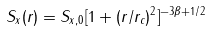Convert formula to latex. <formula><loc_0><loc_0><loc_500><loc_500>S _ { x } ( r ) = S _ { x , 0 } [ 1 + ( r / r _ { c } ) ^ { 2 } ] ^ { - 3 \beta + 1 / 2 }</formula> 